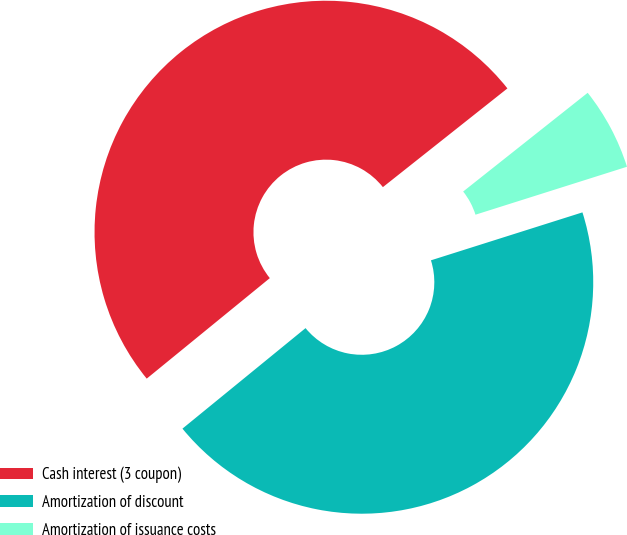Convert chart. <chart><loc_0><loc_0><loc_500><loc_500><pie_chart><fcel>Cash interest (3 coupon)<fcel>Amortization of discount<fcel>Amortization of issuance costs<nl><fcel>50.23%<fcel>43.98%<fcel>5.79%<nl></chart> 